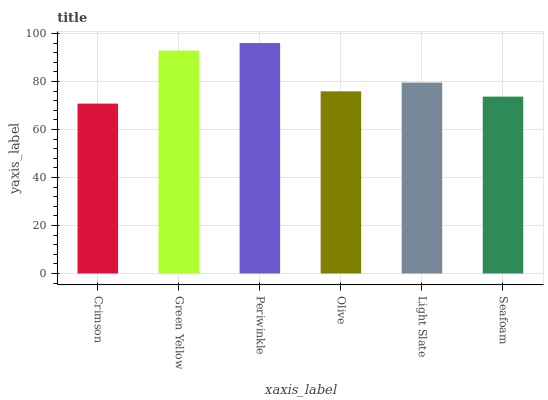Is Crimson the minimum?
Answer yes or no. Yes. Is Periwinkle the maximum?
Answer yes or no. Yes. Is Green Yellow the minimum?
Answer yes or no. No. Is Green Yellow the maximum?
Answer yes or no. No. Is Green Yellow greater than Crimson?
Answer yes or no. Yes. Is Crimson less than Green Yellow?
Answer yes or no. Yes. Is Crimson greater than Green Yellow?
Answer yes or no. No. Is Green Yellow less than Crimson?
Answer yes or no. No. Is Light Slate the high median?
Answer yes or no. Yes. Is Olive the low median?
Answer yes or no. Yes. Is Seafoam the high median?
Answer yes or no. No. Is Periwinkle the low median?
Answer yes or no. No. 